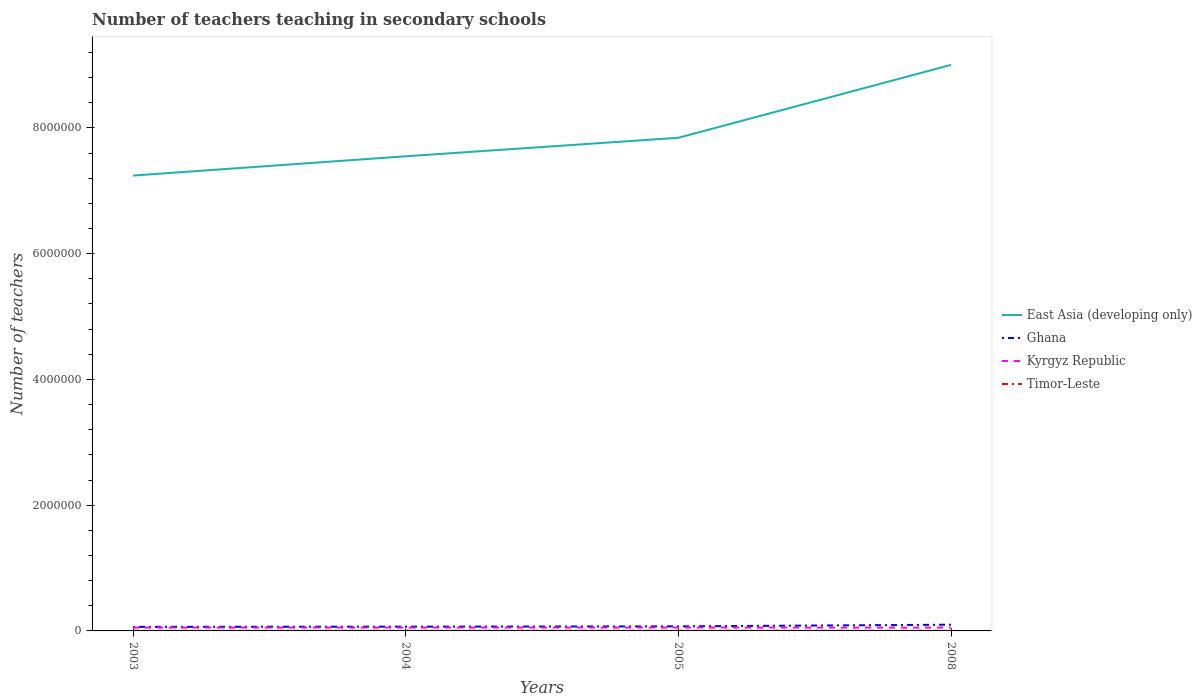Is the number of lines equal to the number of legend labels?
Offer a terse response. Yes. Across all years, what is the maximum number of teachers teaching in secondary schools in Timor-Leste?
Make the answer very short. 1700. In which year was the number of teachers teaching in secondary schools in Timor-Leste maximum?
Make the answer very short. 2003. What is the total number of teachers teaching in secondary schools in Timor-Leste in the graph?
Offer a very short reply. -1460. What is the difference between the highest and the second highest number of teachers teaching in secondary schools in East Asia (developing only)?
Provide a succinct answer. 1.76e+06. How many years are there in the graph?
Your answer should be compact. 4. What is the difference between two consecutive major ticks on the Y-axis?
Offer a very short reply. 2.00e+06. Are the values on the major ticks of Y-axis written in scientific E-notation?
Your answer should be very brief. No. Does the graph contain grids?
Your answer should be compact. No. How many legend labels are there?
Offer a very short reply. 4. What is the title of the graph?
Offer a terse response. Number of teachers teaching in secondary schools. What is the label or title of the X-axis?
Offer a terse response. Years. What is the label or title of the Y-axis?
Offer a very short reply. Number of teachers. What is the Number of teachers in East Asia (developing only) in 2003?
Provide a succinct answer. 7.24e+06. What is the Number of teachers of Ghana in 2003?
Provide a succinct answer. 6.44e+04. What is the Number of teachers of Kyrgyz Republic in 2003?
Offer a very short reply. 5.27e+04. What is the Number of teachers of Timor-Leste in 2003?
Make the answer very short. 1700. What is the Number of teachers in East Asia (developing only) in 2004?
Offer a terse response. 7.55e+06. What is the Number of teachers of Ghana in 2004?
Your response must be concise. 6.79e+04. What is the Number of teachers of Kyrgyz Republic in 2004?
Provide a short and direct response. 5.33e+04. What is the Number of teachers in Timor-Leste in 2004?
Give a very brief answer. 2644. What is the Number of teachers in East Asia (developing only) in 2005?
Provide a succinct answer. 7.84e+06. What is the Number of teachers of Ghana in 2005?
Ensure brevity in your answer.  7.25e+04. What is the Number of teachers in Kyrgyz Republic in 2005?
Offer a very short reply. 5.38e+04. What is the Number of teachers in Timor-Leste in 2005?
Your answer should be compact. 3160. What is the Number of teachers of East Asia (developing only) in 2008?
Make the answer very short. 9.00e+06. What is the Number of teachers in Ghana in 2008?
Offer a very short reply. 9.90e+04. What is the Number of teachers in Kyrgyz Republic in 2008?
Your answer should be compact. 5.25e+04. What is the Number of teachers of Timor-Leste in 2008?
Provide a short and direct response. 2444. Across all years, what is the maximum Number of teachers in East Asia (developing only)?
Provide a short and direct response. 9.00e+06. Across all years, what is the maximum Number of teachers in Ghana?
Provide a succinct answer. 9.90e+04. Across all years, what is the maximum Number of teachers in Kyrgyz Republic?
Give a very brief answer. 5.38e+04. Across all years, what is the maximum Number of teachers in Timor-Leste?
Offer a very short reply. 3160. Across all years, what is the minimum Number of teachers of East Asia (developing only)?
Your response must be concise. 7.24e+06. Across all years, what is the minimum Number of teachers in Ghana?
Offer a terse response. 6.44e+04. Across all years, what is the minimum Number of teachers of Kyrgyz Republic?
Provide a short and direct response. 5.25e+04. Across all years, what is the minimum Number of teachers in Timor-Leste?
Your response must be concise. 1700. What is the total Number of teachers of East Asia (developing only) in the graph?
Offer a very short reply. 3.16e+07. What is the total Number of teachers in Ghana in the graph?
Your answer should be compact. 3.04e+05. What is the total Number of teachers of Kyrgyz Republic in the graph?
Make the answer very short. 2.12e+05. What is the total Number of teachers of Timor-Leste in the graph?
Provide a succinct answer. 9948. What is the difference between the Number of teachers in East Asia (developing only) in 2003 and that in 2004?
Provide a succinct answer. -3.07e+05. What is the difference between the Number of teachers of Ghana in 2003 and that in 2004?
Provide a short and direct response. -3527. What is the difference between the Number of teachers in Kyrgyz Republic in 2003 and that in 2004?
Offer a terse response. -645. What is the difference between the Number of teachers of Timor-Leste in 2003 and that in 2004?
Your answer should be compact. -944. What is the difference between the Number of teachers of East Asia (developing only) in 2003 and that in 2005?
Your answer should be very brief. -6.01e+05. What is the difference between the Number of teachers in Ghana in 2003 and that in 2005?
Offer a terse response. -8083. What is the difference between the Number of teachers in Kyrgyz Republic in 2003 and that in 2005?
Make the answer very short. -1099. What is the difference between the Number of teachers in Timor-Leste in 2003 and that in 2005?
Offer a terse response. -1460. What is the difference between the Number of teachers of East Asia (developing only) in 2003 and that in 2008?
Offer a terse response. -1.76e+06. What is the difference between the Number of teachers in Ghana in 2003 and that in 2008?
Your answer should be compact. -3.46e+04. What is the difference between the Number of teachers of Kyrgyz Republic in 2003 and that in 2008?
Your answer should be compact. 168. What is the difference between the Number of teachers of Timor-Leste in 2003 and that in 2008?
Offer a terse response. -744. What is the difference between the Number of teachers in East Asia (developing only) in 2004 and that in 2005?
Keep it short and to the point. -2.94e+05. What is the difference between the Number of teachers in Ghana in 2004 and that in 2005?
Keep it short and to the point. -4556. What is the difference between the Number of teachers in Kyrgyz Republic in 2004 and that in 2005?
Provide a succinct answer. -454. What is the difference between the Number of teachers in Timor-Leste in 2004 and that in 2005?
Offer a very short reply. -516. What is the difference between the Number of teachers in East Asia (developing only) in 2004 and that in 2008?
Ensure brevity in your answer.  -1.45e+06. What is the difference between the Number of teachers of Ghana in 2004 and that in 2008?
Give a very brief answer. -3.11e+04. What is the difference between the Number of teachers of Kyrgyz Republic in 2004 and that in 2008?
Make the answer very short. 813. What is the difference between the Number of teachers of East Asia (developing only) in 2005 and that in 2008?
Your answer should be compact. -1.16e+06. What is the difference between the Number of teachers of Ghana in 2005 and that in 2008?
Give a very brief answer. -2.65e+04. What is the difference between the Number of teachers in Kyrgyz Republic in 2005 and that in 2008?
Make the answer very short. 1267. What is the difference between the Number of teachers of Timor-Leste in 2005 and that in 2008?
Provide a succinct answer. 716. What is the difference between the Number of teachers of East Asia (developing only) in 2003 and the Number of teachers of Ghana in 2004?
Give a very brief answer. 7.17e+06. What is the difference between the Number of teachers of East Asia (developing only) in 2003 and the Number of teachers of Kyrgyz Republic in 2004?
Provide a succinct answer. 7.19e+06. What is the difference between the Number of teachers of East Asia (developing only) in 2003 and the Number of teachers of Timor-Leste in 2004?
Your answer should be compact. 7.24e+06. What is the difference between the Number of teachers in Ghana in 2003 and the Number of teachers in Kyrgyz Republic in 2004?
Offer a very short reply. 1.11e+04. What is the difference between the Number of teachers in Ghana in 2003 and the Number of teachers in Timor-Leste in 2004?
Keep it short and to the point. 6.18e+04. What is the difference between the Number of teachers in Kyrgyz Republic in 2003 and the Number of teachers in Timor-Leste in 2004?
Make the answer very short. 5.00e+04. What is the difference between the Number of teachers of East Asia (developing only) in 2003 and the Number of teachers of Ghana in 2005?
Provide a succinct answer. 7.17e+06. What is the difference between the Number of teachers of East Asia (developing only) in 2003 and the Number of teachers of Kyrgyz Republic in 2005?
Your response must be concise. 7.19e+06. What is the difference between the Number of teachers of East Asia (developing only) in 2003 and the Number of teachers of Timor-Leste in 2005?
Your answer should be compact. 7.24e+06. What is the difference between the Number of teachers of Ghana in 2003 and the Number of teachers of Kyrgyz Republic in 2005?
Offer a terse response. 1.07e+04. What is the difference between the Number of teachers of Ghana in 2003 and the Number of teachers of Timor-Leste in 2005?
Provide a succinct answer. 6.13e+04. What is the difference between the Number of teachers of Kyrgyz Republic in 2003 and the Number of teachers of Timor-Leste in 2005?
Keep it short and to the point. 4.95e+04. What is the difference between the Number of teachers in East Asia (developing only) in 2003 and the Number of teachers in Ghana in 2008?
Keep it short and to the point. 7.14e+06. What is the difference between the Number of teachers of East Asia (developing only) in 2003 and the Number of teachers of Kyrgyz Republic in 2008?
Make the answer very short. 7.19e+06. What is the difference between the Number of teachers in East Asia (developing only) in 2003 and the Number of teachers in Timor-Leste in 2008?
Provide a short and direct response. 7.24e+06. What is the difference between the Number of teachers of Ghana in 2003 and the Number of teachers of Kyrgyz Republic in 2008?
Provide a short and direct response. 1.19e+04. What is the difference between the Number of teachers of Ghana in 2003 and the Number of teachers of Timor-Leste in 2008?
Your answer should be compact. 6.20e+04. What is the difference between the Number of teachers of Kyrgyz Republic in 2003 and the Number of teachers of Timor-Leste in 2008?
Your response must be concise. 5.02e+04. What is the difference between the Number of teachers of East Asia (developing only) in 2004 and the Number of teachers of Ghana in 2005?
Ensure brevity in your answer.  7.48e+06. What is the difference between the Number of teachers of East Asia (developing only) in 2004 and the Number of teachers of Kyrgyz Republic in 2005?
Your response must be concise. 7.49e+06. What is the difference between the Number of teachers in East Asia (developing only) in 2004 and the Number of teachers in Timor-Leste in 2005?
Provide a succinct answer. 7.55e+06. What is the difference between the Number of teachers of Ghana in 2004 and the Number of teachers of Kyrgyz Republic in 2005?
Offer a very short reply. 1.42e+04. What is the difference between the Number of teachers in Ghana in 2004 and the Number of teachers in Timor-Leste in 2005?
Give a very brief answer. 6.48e+04. What is the difference between the Number of teachers in Kyrgyz Republic in 2004 and the Number of teachers in Timor-Leste in 2005?
Your answer should be compact. 5.01e+04. What is the difference between the Number of teachers of East Asia (developing only) in 2004 and the Number of teachers of Ghana in 2008?
Ensure brevity in your answer.  7.45e+06. What is the difference between the Number of teachers in East Asia (developing only) in 2004 and the Number of teachers in Kyrgyz Republic in 2008?
Your answer should be compact. 7.50e+06. What is the difference between the Number of teachers of East Asia (developing only) in 2004 and the Number of teachers of Timor-Leste in 2008?
Keep it short and to the point. 7.55e+06. What is the difference between the Number of teachers in Ghana in 2004 and the Number of teachers in Kyrgyz Republic in 2008?
Your answer should be compact. 1.55e+04. What is the difference between the Number of teachers in Ghana in 2004 and the Number of teachers in Timor-Leste in 2008?
Make the answer very short. 6.55e+04. What is the difference between the Number of teachers of Kyrgyz Republic in 2004 and the Number of teachers of Timor-Leste in 2008?
Offer a very short reply. 5.09e+04. What is the difference between the Number of teachers in East Asia (developing only) in 2005 and the Number of teachers in Ghana in 2008?
Provide a succinct answer. 7.74e+06. What is the difference between the Number of teachers in East Asia (developing only) in 2005 and the Number of teachers in Kyrgyz Republic in 2008?
Keep it short and to the point. 7.79e+06. What is the difference between the Number of teachers in East Asia (developing only) in 2005 and the Number of teachers in Timor-Leste in 2008?
Your answer should be compact. 7.84e+06. What is the difference between the Number of teachers of Ghana in 2005 and the Number of teachers of Kyrgyz Republic in 2008?
Make the answer very short. 2.00e+04. What is the difference between the Number of teachers of Ghana in 2005 and the Number of teachers of Timor-Leste in 2008?
Make the answer very short. 7.01e+04. What is the difference between the Number of teachers in Kyrgyz Republic in 2005 and the Number of teachers in Timor-Leste in 2008?
Make the answer very short. 5.13e+04. What is the average Number of teachers of East Asia (developing only) per year?
Your response must be concise. 7.91e+06. What is the average Number of teachers of Ghana per year?
Your answer should be very brief. 7.60e+04. What is the average Number of teachers of Kyrgyz Republic per year?
Your answer should be compact. 5.30e+04. What is the average Number of teachers in Timor-Leste per year?
Offer a very short reply. 2487. In the year 2003, what is the difference between the Number of teachers in East Asia (developing only) and Number of teachers in Ghana?
Provide a succinct answer. 7.18e+06. In the year 2003, what is the difference between the Number of teachers of East Asia (developing only) and Number of teachers of Kyrgyz Republic?
Offer a terse response. 7.19e+06. In the year 2003, what is the difference between the Number of teachers in East Asia (developing only) and Number of teachers in Timor-Leste?
Your answer should be compact. 7.24e+06. In the year 2003, what is the difference between the Number of teachers in Ghana and Number of teachers in Kyrgyz Republic?
Provide a short and direct response. 1.18e+04. In the year 2003, what is the difference between the Number of teachers of Ghana and Number of teachers of Timor-Leste?
Your response must be concise. 6.27e+04. In the year 2003, what is the difference between the Number of teachers in Kyrgyz Republic and Number of teachers in Timor-Leste?
Offer a very short reply. 5.10e+04. In the year 2004, what is the difference between the Number of teachers in East Asia (developing only) and Number of teachers in Ghana?
Make the answer very short. 7.48e+06. In the year 2004, what is the difference between the Number of teachers of East Asia (developing only) and Number of teachers of Kyrgyz Republic?
Offer a very short reply. 7.50e+06. In the year 2004, what is the difference between the Number of teachers of East Asia (developing only) and Number of teachers of Timor-Leste?
Ensure brevity in your answer.  7.55e+06. In the year 2004, what is the difference between the Number of teachers of Ghana and Number of teachers of Kyrgyz Republic?
Offer a terse response. 1.46e+04. In the year 2004, what is the difference between the Number of teachers in Ghana and Number of teachers in Timor-Leste?
Make the answer very short. 6.53e+04. In the year 2004, what is the difference between the Number of teachers of Kyrgyz Republic and Number of teachers of Timor-Leste?
Offer a terse response. 5.07e+04. In the year 2005, what is the difference between the Number of teachers of East Asia (developing only) and Number of teachers of Ghana?
Your answer should be very brief. 7.77e+06. In the year 2005, what is the difference between the Number of teachers in East Asia (developing only) and Number of teachers in Kyrgyz Republic?
Give a very brief answer. 7.79e+06. In the year 2005, what is the difference between the Number of teachers of East Asia (developing only) and Number of teachers of Timor-Leste?
Your answer should be compact. 7.84e+06. In the year 2005, what is the difference between the Number of teachers in Ghana and Number of teachers in Kyrgyz Republic?
Your answer should be very brief. 1.87e+04. In the year 2005, what is the difference between the Number of teachers of Ghana and Number of teachers of Timor-Leste?
Your answer should be compact. 6.93e+04. In the year 2005, what is the difference between the Number of teachers of Kyrgyz Republic and Number of teachers of Timor-Leste?
Your response must be concise. 5.06e+04. In the year 2008, what is the difference between the Number of teachers in East Asia (developing only) and Number of teachers in Ghana?
Your answer should be very brief. 8.90e+06. In the year 2008, what is the difference between the Number of teachers in East Asia (developing only) and Number of teachers in Kyrgyz Republic?
Your answer should be very brief. 8.95e+06. In the year 2008, what is the difference between the Number of teachers of East Asia (developing only) and Number of teachers of Timor-Leste?
Your response must be concise. 9.00e+06. In the year 2008, what is the difference between the Number of teachers of Ghana and Number of teachers of Kyrgyz Republic?
Ensure brevity in your answer.  4.65e+04. In the year 2008, what is the difference between the Number of teachers in Ghana and Number of teachers in Timor-Leste?
Give a very brief answer. 9.66e+04. In the year 2008, what is the difference between the Number of teachers in Kyrgyz Republic and Number of teachers in Timor-Leste?
Ensure brevity in your answer.  5.00e+04. What is the ratio of the Number of teachers of East Asia (developing only) in 2003 to that in 2004?
Offer a very short reply. 0.96. What is the ratio of the Number of teachers of Ghana in 2003 to that in 2004?
Your response must be concise. 0.95. What is the ratio of the Number of teachers of Kyrgyz Republic in 2003 to that in 2004?
Offer a very short reply. 0.99. What is the ratio of the Number of teachers in Timor-Leste in 2003 to that in 2004?
Provide a succinct answer. 0.64. What is the ratio of the Number of teachers in East Asia (developing only) in 2003 to that in 2005?
Your answer should be very brief. 0.92. What is the ratio of the Number of teachers in Ghana in 2003 to that in 2005?
Your answer should be compact. 0.89. What is the ratio of the Number of teachers in Kyrgyz Republic in 2003 to that in 2005?
Offer a terse response. 0.98. What is the ratio of the Number of teachers in Timor-Leste in 2003 to that in 2005?
Provide a succinct answer. 0.54. What is the ratio of the Number of teachers of East Asia (developing only) in 2003 to that in 2008?
Your response must be concise. 0.8. What is the ratio of the Number of teachers in Ghana in 2003 to that in 2008?
Give a very brief answer. 0.65. What is the ratio of the Number of teachers in Kyrgyz Republic in 2003 to that in 2008?
Provide a succinct answer. 1. What is the ratio of the Number of teachers in Timor-Leste in 2003 to that in 2008?
Give a very brief answer. 0.7. What is the ratio of the Number of teachers in East Asia (developing only) in 2004 to that in 2005?
Your response must be concise. 0.96. What is the ratio of the Number of teachers in Ghana in 2004 to that in 2005?
Your answer should be very brief. 0.94. What is the ratio of the Number of teachers in Kyrgyz Republic in 2004 to that in 2005?
Keep it short and to the point. 0.99. What is the ratio of the Number of teachers of Timor-Leste in 2004 to that in 2005?
Provide a short and direct response. 0.84. What is the ratio of the Number of teachers in East Asia (developing only) in 2004 to that in 2008?
Make the answer very short. 0.84. What is the ratio of the Number of teachers in Ghana in 2004 to that in 2008?
Offer a terse response. 0.69. What is the ratio of the Number of teachers of Kyrgyz Republic in 2004 to that in 2008?
Keep it short and to the point. 1.02. What is the ratio of the Number of teachers of Timor-Leste in 2004 to that in 2008?
Provide a short and direct response. 1.08. What is the ratio of the Number of teachers of East Asia (developing only) in 2005 to that in 2008?
Your answer should be very brief. 0.87. What is the ratio of the Number of teachers in Ghana in 2005 to that in 2008?
Give a very brief answer. 0.73. What is the ratio of the Number of teachers of Kyrgyz Republic in 2005 to that in 2008?
Your answer should be compact. 1.02. What is the ratio of the Number of teachers of Timor-Leste in 2005 to that in 2008?
Your response must be concise. 1.29. What is the difference between the highest and the second highest Number of teachers of East Asia (developing only)?
Make the answer very short. 1.16e+06. What is the difference between the highest and the second highest Number of teachers in Ghana?
Your response must be concise. 2.65e+04. What is the difference between the highest and the second highest Number of teachers in Kyrgyz Republic?
Make the answer very short. 454. What is the difference between the highest and the second highest Number of teachers of Timor-Leste?
Your answer should be compact. 516. What is the difference between the highest and the lowest Number of teachers of East Asia (developing only)?
Offer a very short reply. 1.76e+06. What is the difference between the highest and the lowest Number of teachers of Ghana?
Your answer should be very brief. 3.46e+04. What is the difference between the highest and the lowest Number of teachers of Kyrgyz Republic?
Offer a terse response. 1267. What is the difference between the highest and the lowest Number of teachers of Timor-Leste?
Provide a short and direct response. 1460. 